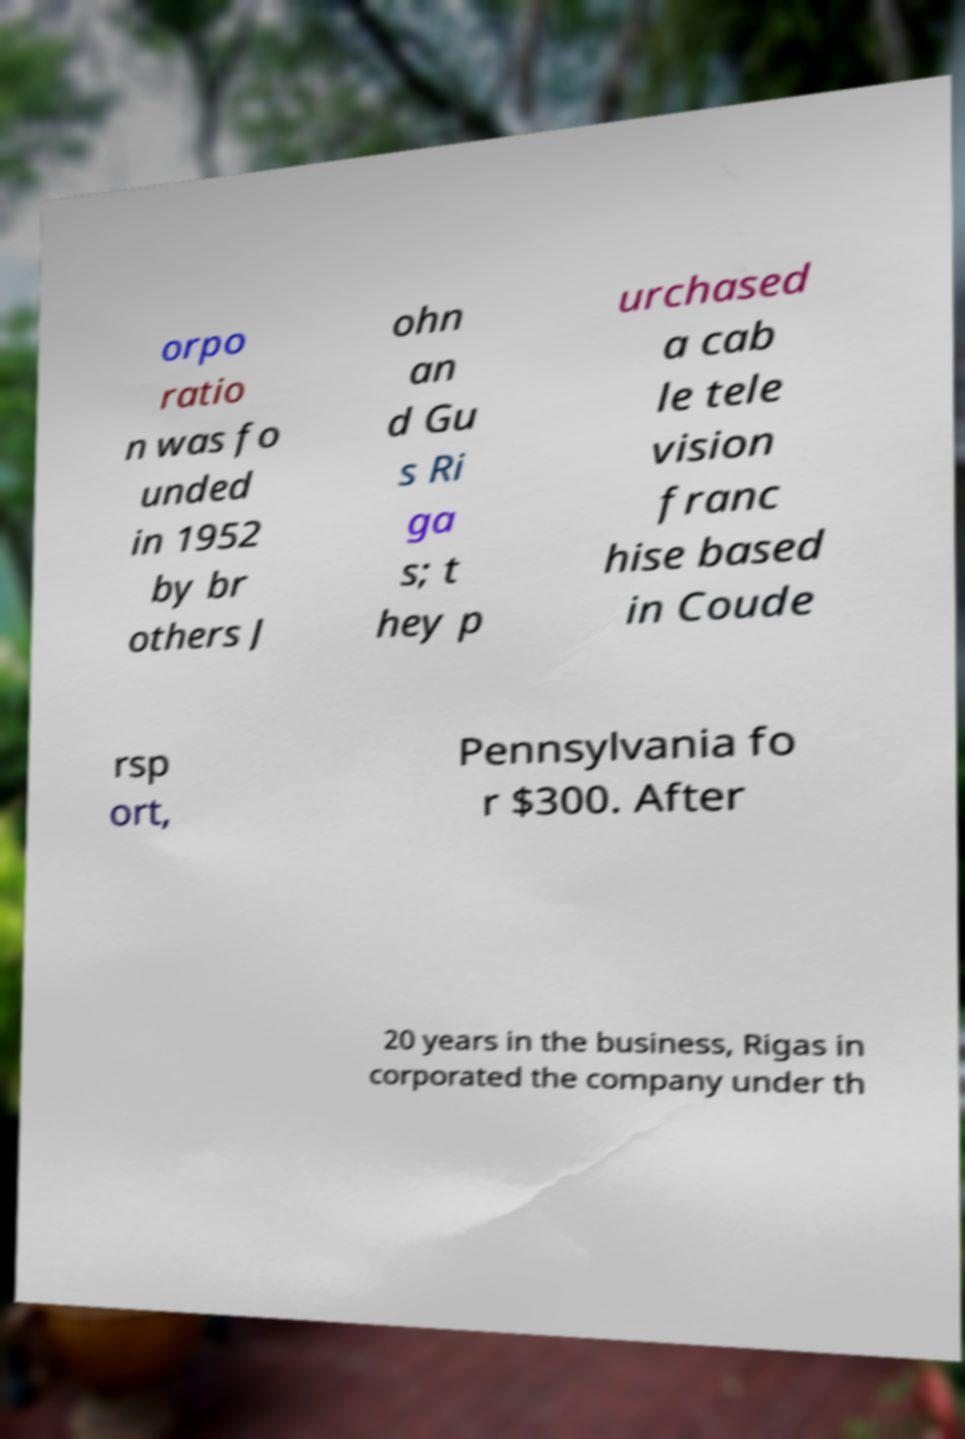Please read and relay the text visible in this image. What does it say? orpo ratio n was fo unded in 1952 by br others J ohn an d Gu s Ri ga s; t hey p urchased a cab le tele vision franc hise based in Coude rsp ort, Pennsylvania fo r $300. After 20 years in the business, Rigas in corporated the company under th 